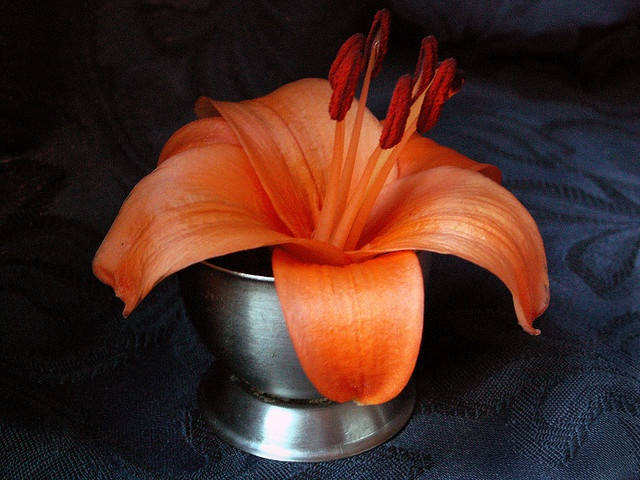Describe the objects in this image and their specific colors. I can see potted plant in black, red, brown, and salmon tones and vase in black, gray, darkgray, and white tones in this image. 